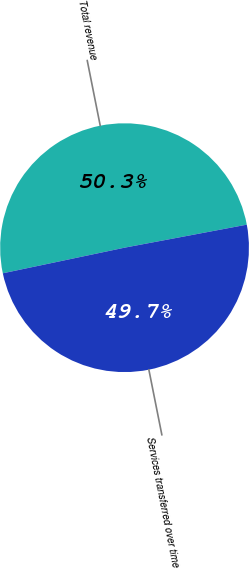Convert chart to OTSL. <chart><loc_0><loc_0><loc_500><loc_500><pie_chart><fcel>Total revenue<fcel>Services transferred over time<nl><fcel>50.34%<fcel>49.66%<nl></chart> 